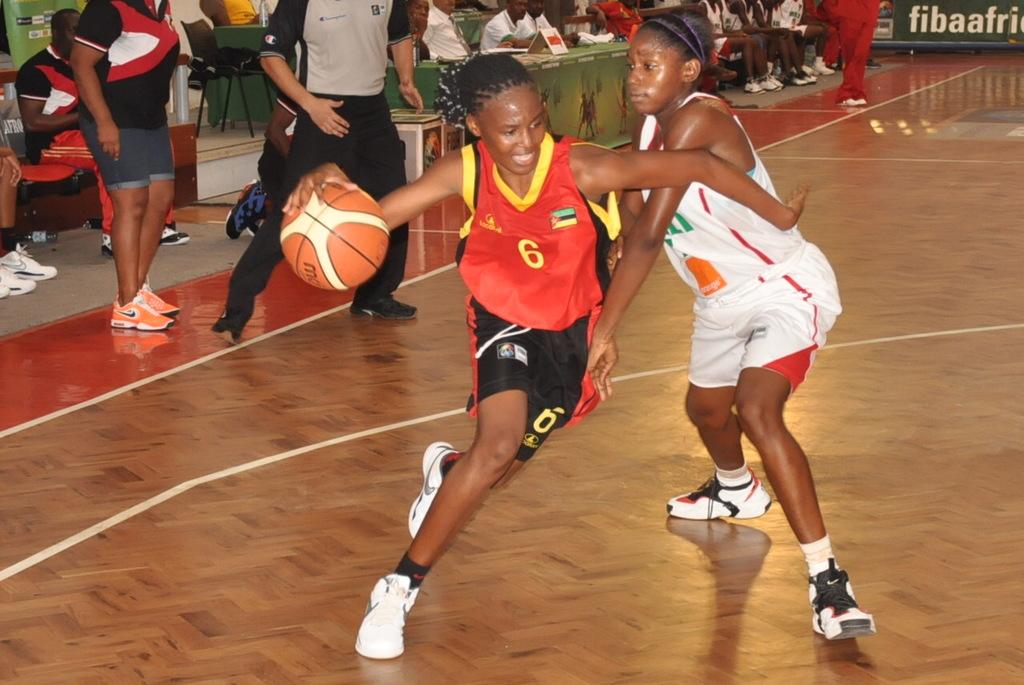What kind of shoes is the player on the right wearing?
Offer a very short reply. Nike. 